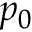Convert formula to latex. <formula><loc_0><loc_0><loc_500><loc_500>p _ { 0 }</formula> 